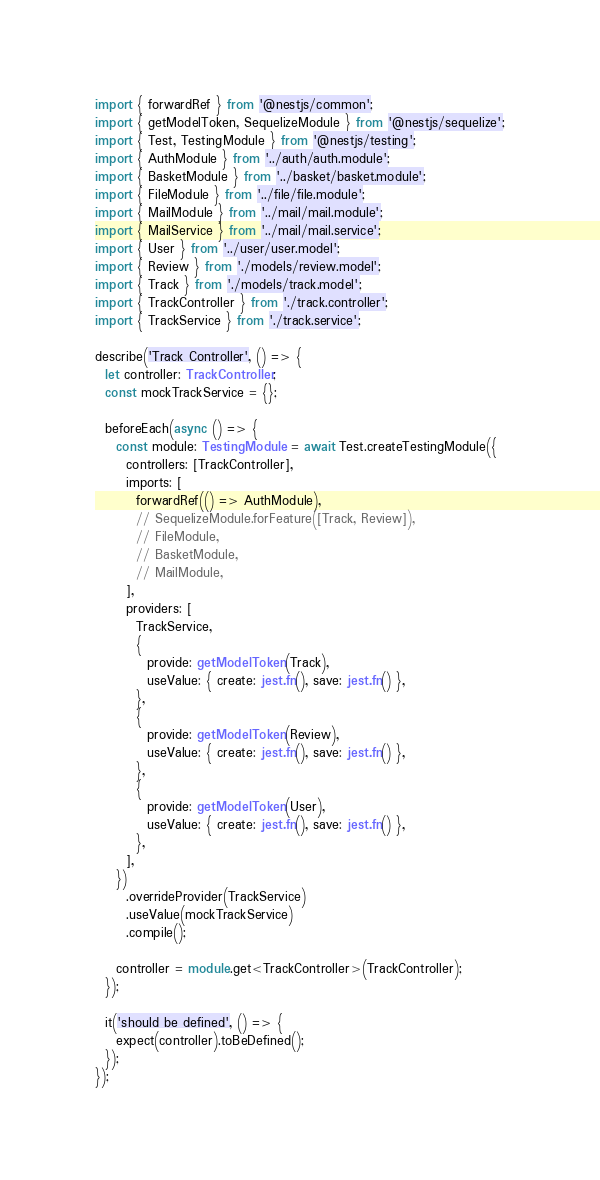Convert code to text. <code><loc_0><loc_0><loc_500><loc_500><_TypeScript_>import { forwardRef } from '@nestjs/common';
import { getModelToken, SequelizeModule } from '@nestjs/sequelize';
import { Test, TestingModule } from '@nestjs/testing';
import { AuthModule } from '../auth/auth.module';
import { BasketModule } from '../basket/basket.module';
import { FileModule } from '../file/file.module';
import { MailModule } from '../mail/mail.module';
import { MailService } from '../mail/mail.service';
import { User } from '../user/user.model';
import { Review } from './models/review.model';
import { Track } from './models/track.model';
import { TrackController } from './track.controller';
import { TrackService } from './track.service';

describe('Track Controller', () => {
  let controller: TrackController;
  const mockTrackService = {};

  beforeEach(async () => {
    const module: TestingModule = await Test.createTestingModule({
      controllers: [TrackController],
      imports: [
        forwardRef(() => AuthModule),
        // SequelizeModule.forFeature([Track, Review]),
        // FileModule,
        // BasketModule,
        // MailModule,
      ],
      providers: [
        TrackService,
        {
          provide: getModelToken(Track),
          useValue: { create: jest.fn(), save: jest.fn() },
        },
        {
          provide: getModelToken(Review),
          useValue: { create: jest.fn(), save: jest.fn() },
        },
        {
          provide: getModelToken(User),
          useValue: { create: jest.fn(), save: jest.fn() },
        },
      ],
    })
      .overrideProvider(TrackService)
      .useValue(mockTrackService)
      .compile();

    controller = module.get<TrackController>(TrackController);
  });

  it('should be defined', () => {
    expect(controller).toBeDefined();
  });
});
</code> 